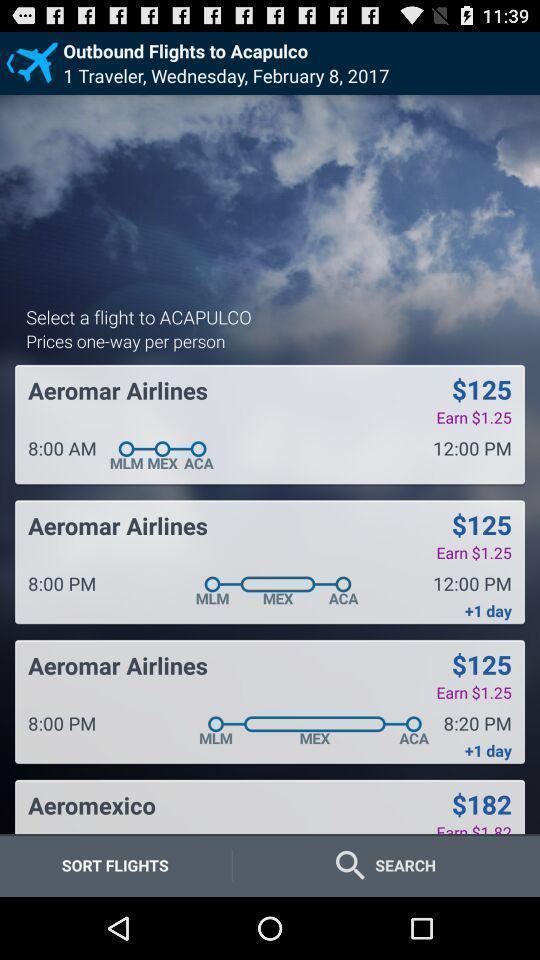What can you discern from this picture? Screen shows list of options in a travel app. 